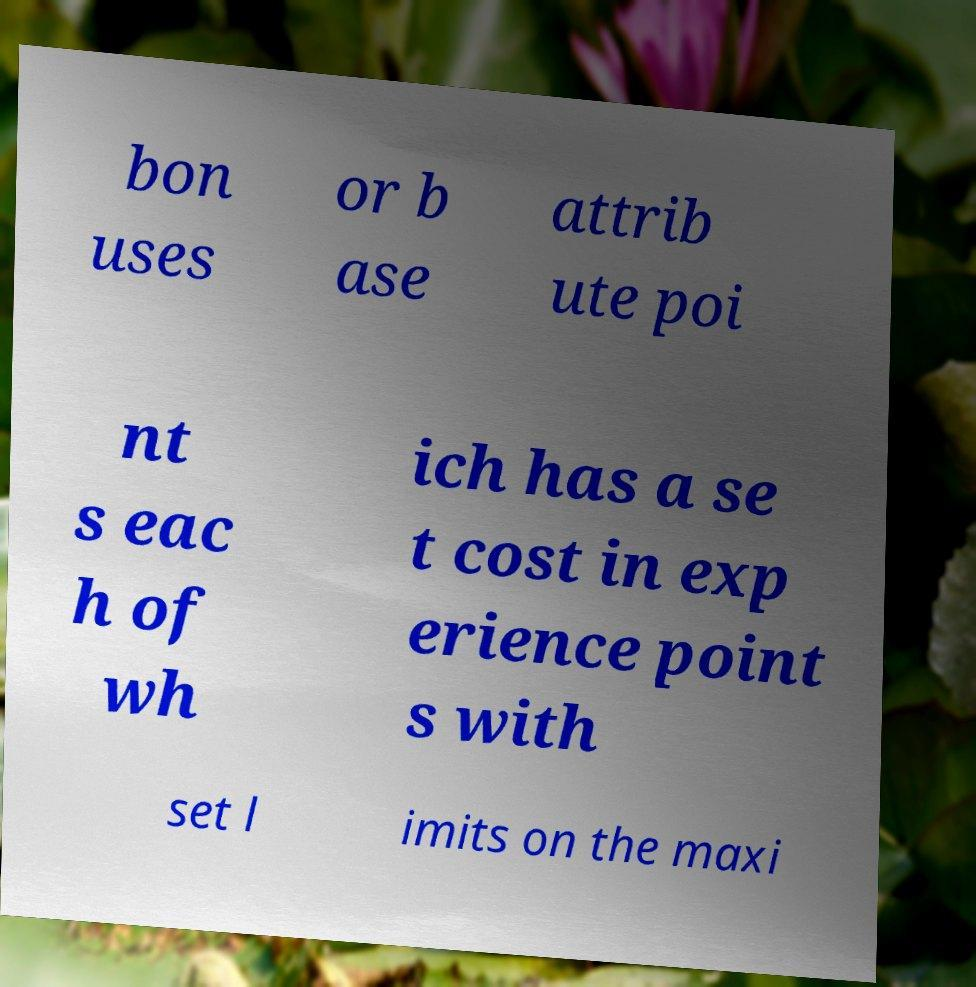Could you extract and type out the text from this image? bon uses or b ase attrib ute poi nt s eac h of wh ich has a se t cost in exp erience point s with set l imits on the maxi 